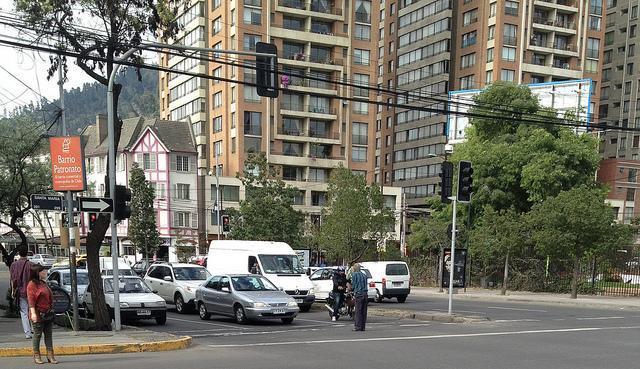How many people are there?
Give a very brief answer. 4. How many cars are there?
Give a very brief answer. 4. 